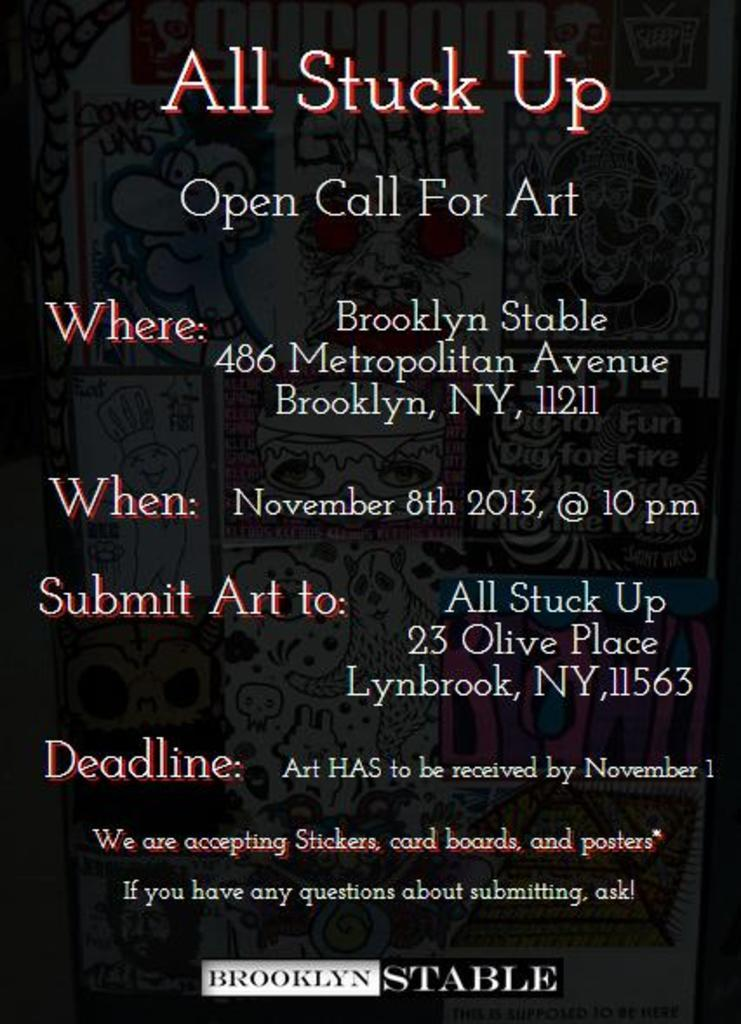<image>
Summarize the visual content of the image. A poster requesting that art be submitted by November 8, 2013. 